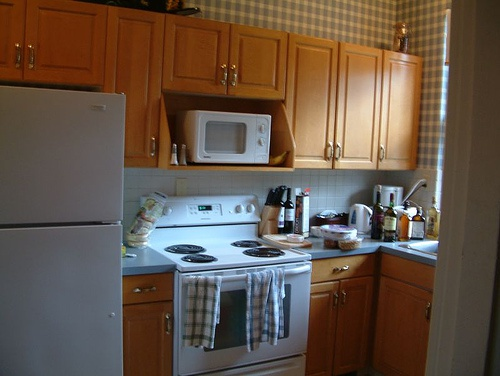Describe the objects in this image and their specific colors. I can see refrigerator in maroon, gray, and black tones, oven in maroon, gray, lightblue, and black tones, microwave in maroon, gray, darkgray, and black tones, bottle in maroon, black, and gray tones, and bowl in maroon, gray, darkgray, and lightblue tones in this image. 